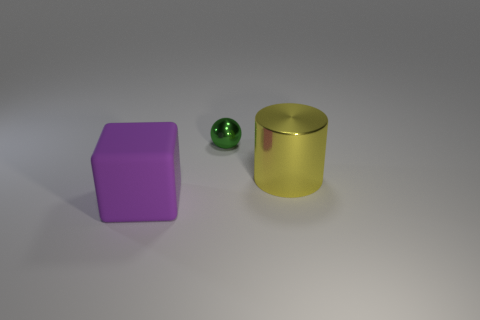What materials are the objects in the image made of? The objects appear to have different materials. The purple object looks to be made of a rubber-like material, the green object has a matte finish that might suggest a ceramic or plastic composition, and the gold object appears metallic, perhaps an anodized aluminum. 